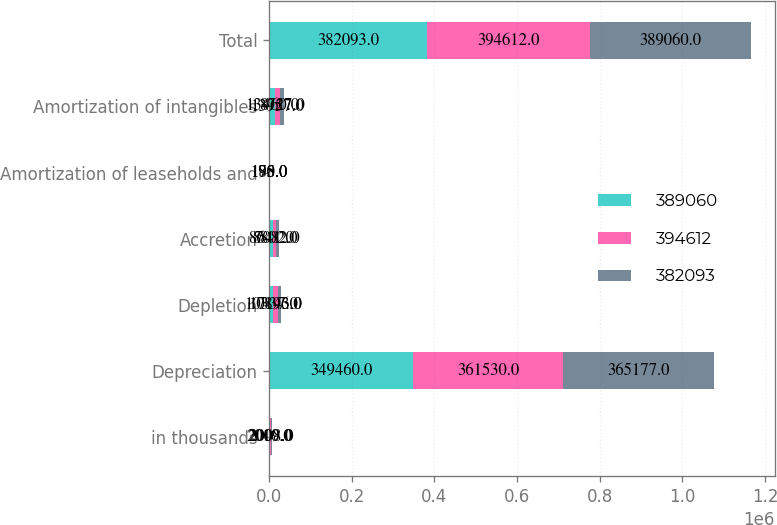<chart> <loc_0><loc_0><loc_500><loc_500><stacked_bar_chart><ecel><fcel>in thousands<fcel>Depreciation<fcel>Depletion<fcel>Accretion<fcel>Amortization of leaseholds and<fcel>Amortization of intangibles<fcel>Total<nl><fcel>389060<fcel>2010<fcel>349460<fcel>10337<fcel>8641<fcel>195<fcel>13460<fcel>382093<nl><fcel>394612<fcel>2009<fcel>361530<fcel>10143<fcel>8802<fcel>180<fcel>13957<fcel>394612<nl><fcel>382093<fcel>2008<fcel>365177<fcel>7896<fcel>7082<fcel>178<fcel>8727<fcel>389060<nl></chart> 